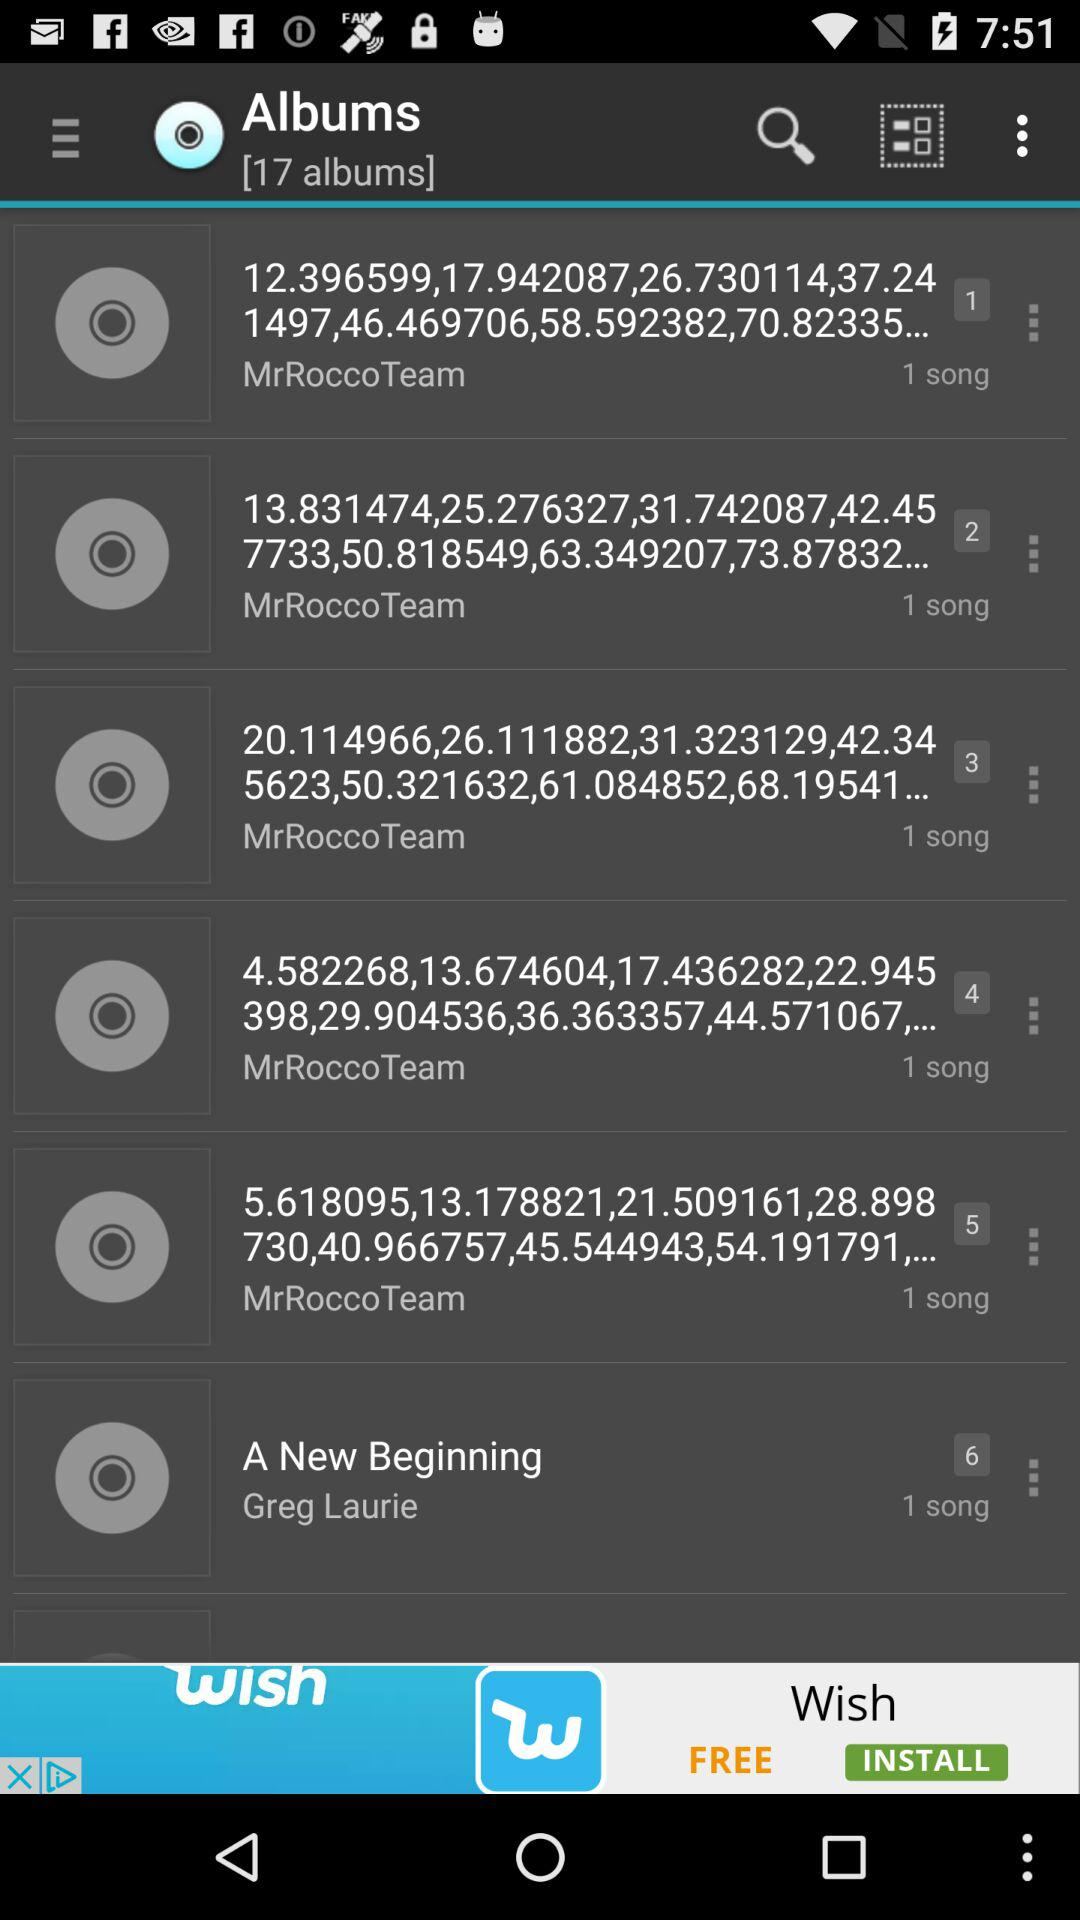Who is the singer of the song "A New Beginning"? The singer is Greg Laurie. 